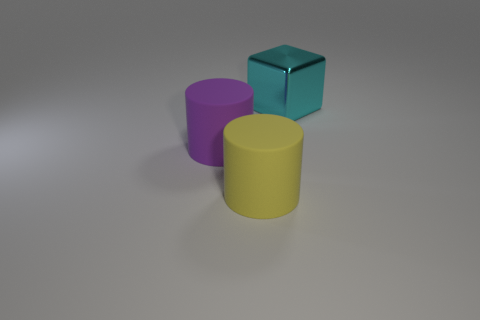Add 2 purple things. How many objects exist? 5 Subtract all blocks. How many objects are left? 2 Subtract 0 blue cylinders. How many objects are left? 3 Subtract all small yellow rubber things. Subtract all yellow cylinders. How many objects are left? 2 Add 2 yellow objects. How many yellow objects are left? 3 Add 1 large cyan rubber cylinders. How many large cyan rubber cylinders exist? 1 